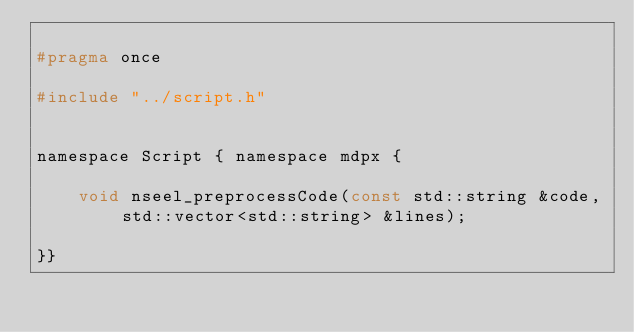<code> <loc_0><loc_0><loc_500><loc_500><_C_>
#pragma once

#include "../script.h"


namespace Script { namespace mdpx {

    void nseel_preprocessCode(const std::string &code, std::vector<std::string> &lines);

}}
</code> 